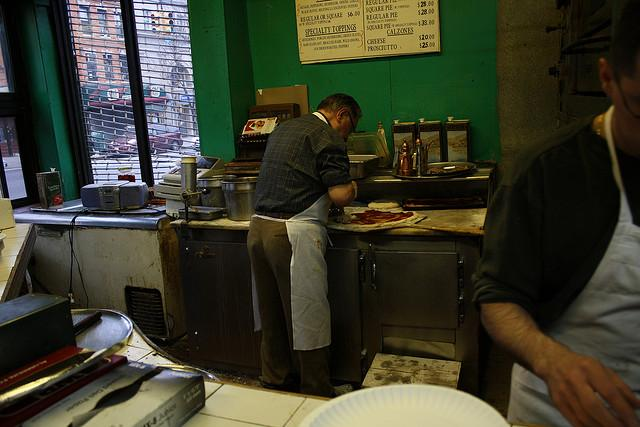Who regularly wore the item the man has over his pants? Please explain your reasoning. rachel ray. Rachel ray is a chef. 